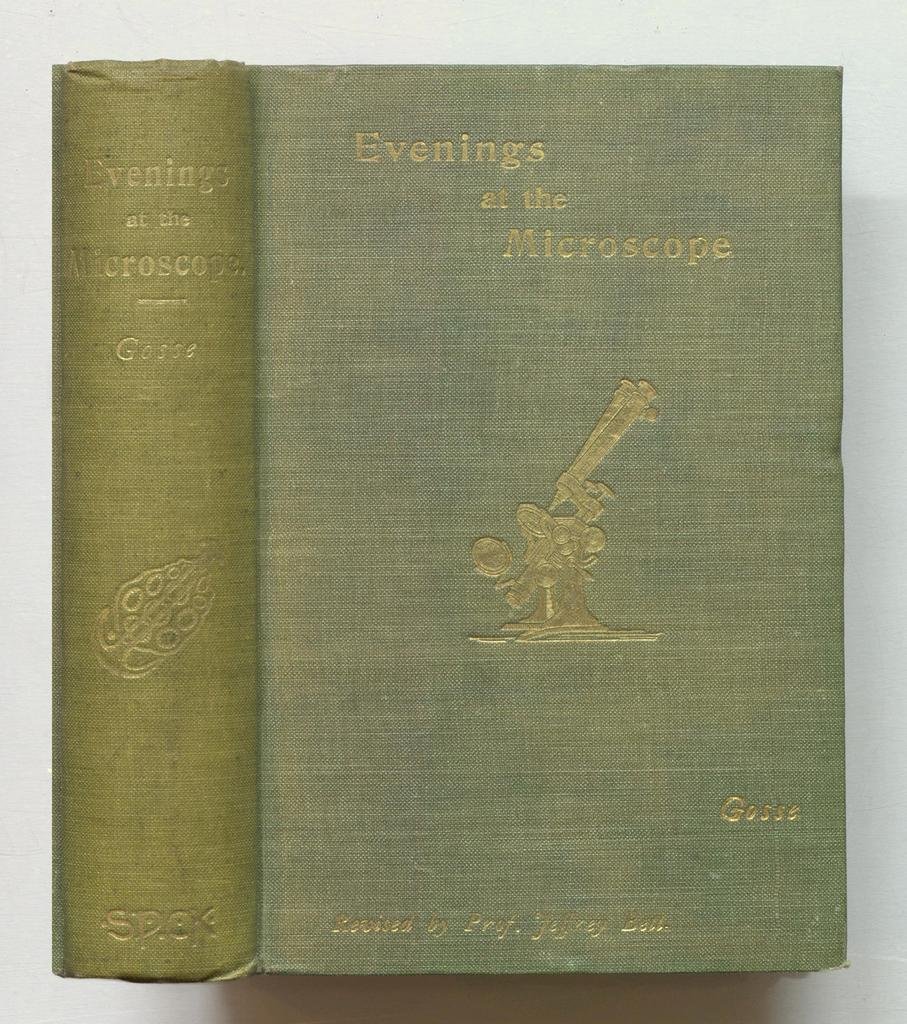<image>
Create a compact narrative representing the image presented. The cover of the book Evenings at the Microscope features a golden microscope. 